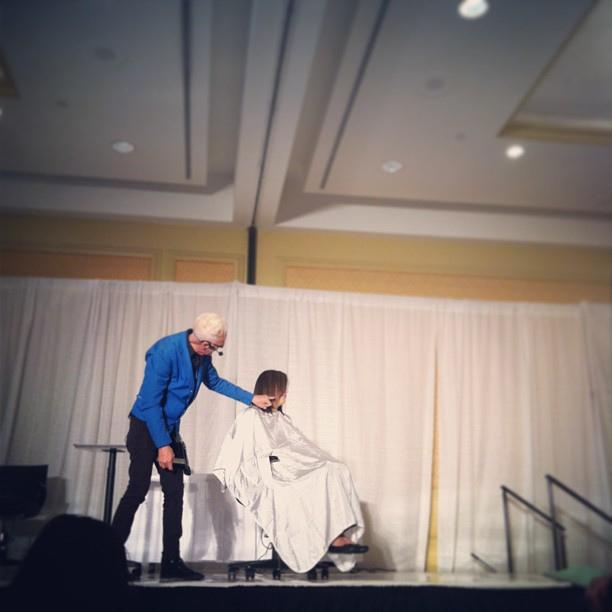What is the woman receiving on the stage?

Choices:
A) haircut
B) award
C) diploma
D) book haircut 